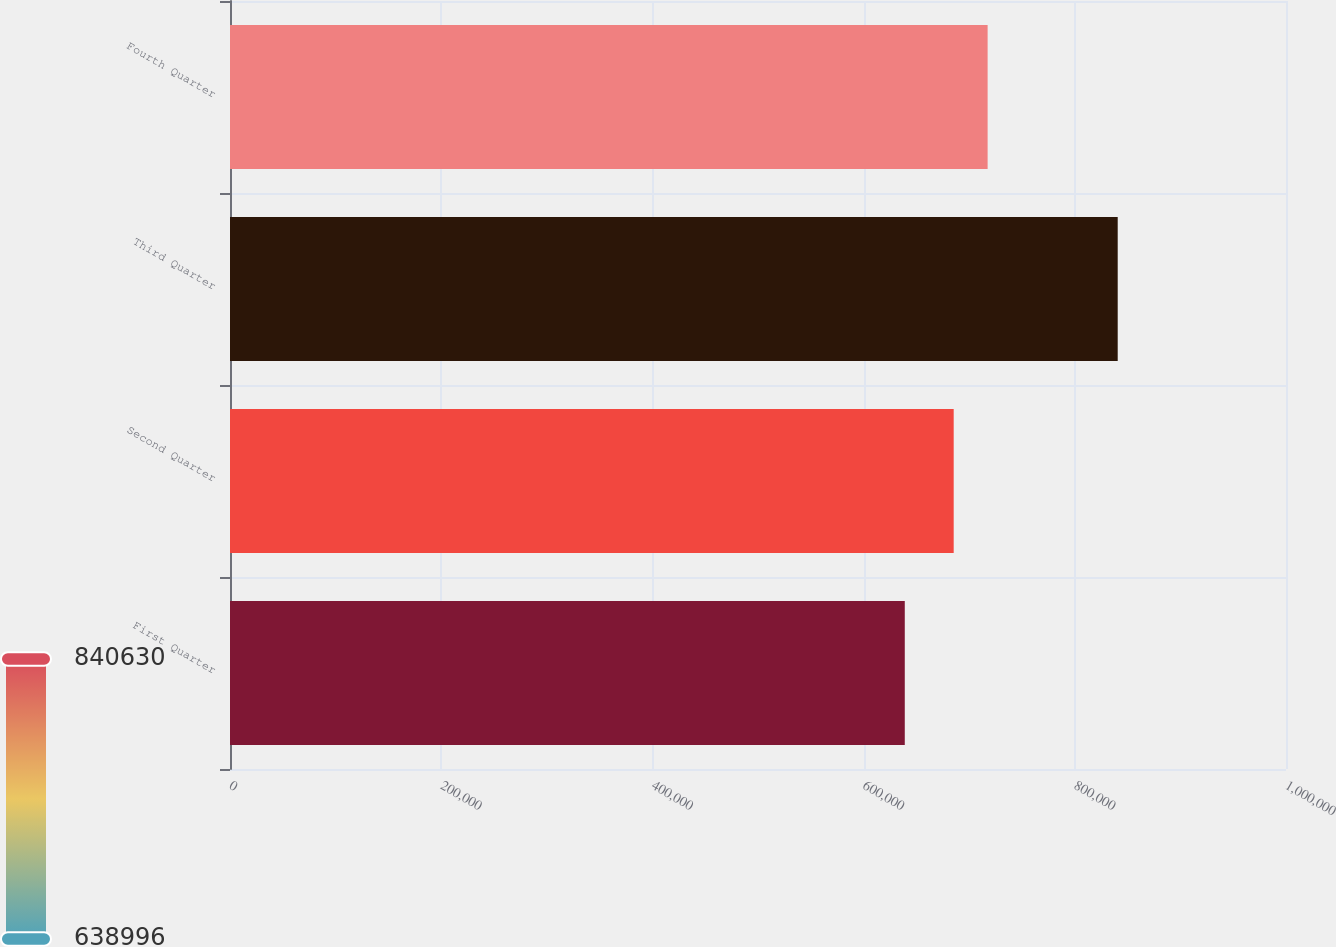Convert chart. <chart><loc_0><loc_0><loc_500><loc_500><bar_chart><fcel>First Quarter<fcel>Second Quarter<fcel>Third Quarter<fcel>Fourth Quarter<nl><fcel>638996<fcel>685313<fcel>840630<fcel>717445<nl></chart> 